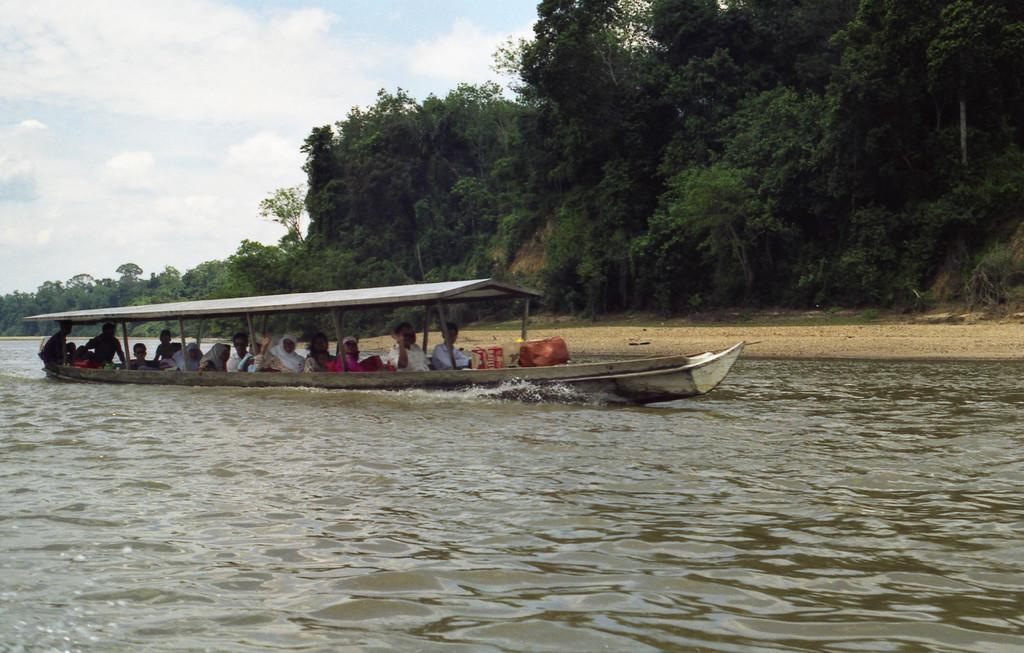What is the main subject of the image? The main subject of the image is a boat. What is the boat doing in the image? The boat is sailing on the water. Are there any people on the boat? Yes, there are persons sitting inside the boat. What can be seen in the background of the image? There are trees in the background of the image. How would you describe the weather in the image? The sky is cloudy in the image. What unit of measurement is being used to determine the boat's attention in the image? There is no indication of the boat's attention in the image, and no unit of measurement is mentioned or implied. --- 